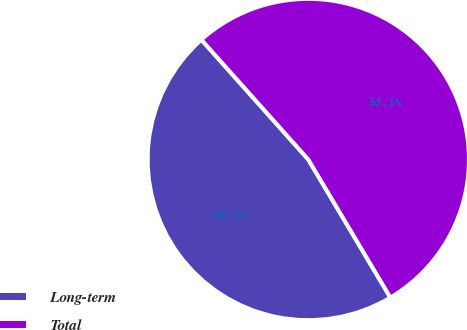<chart> <loc_0><loc_0><loc_500><loc_500><pie_chart><fcel>Long-term<fcel>Total<nl><fcel>46.94%<fcel>53.06%<nl></chart> 